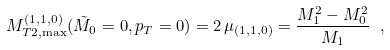<formula> <loc_0><loc_0><loc_500><loc_500>M _ { T 2 , \max } ^ { ( 1 , 1 , 0 ) } ( \tilde { M } _ { 0 } = 0 , p _ { T } = 0 ) = 2 \, \mu _ { ( 1 , 1 , 0 ) } = \frac { M _ { 1 } ^ { 2 } - M _ { 0 } ^ { 2 } } { M _ { 1 } } \ ,</formula> 